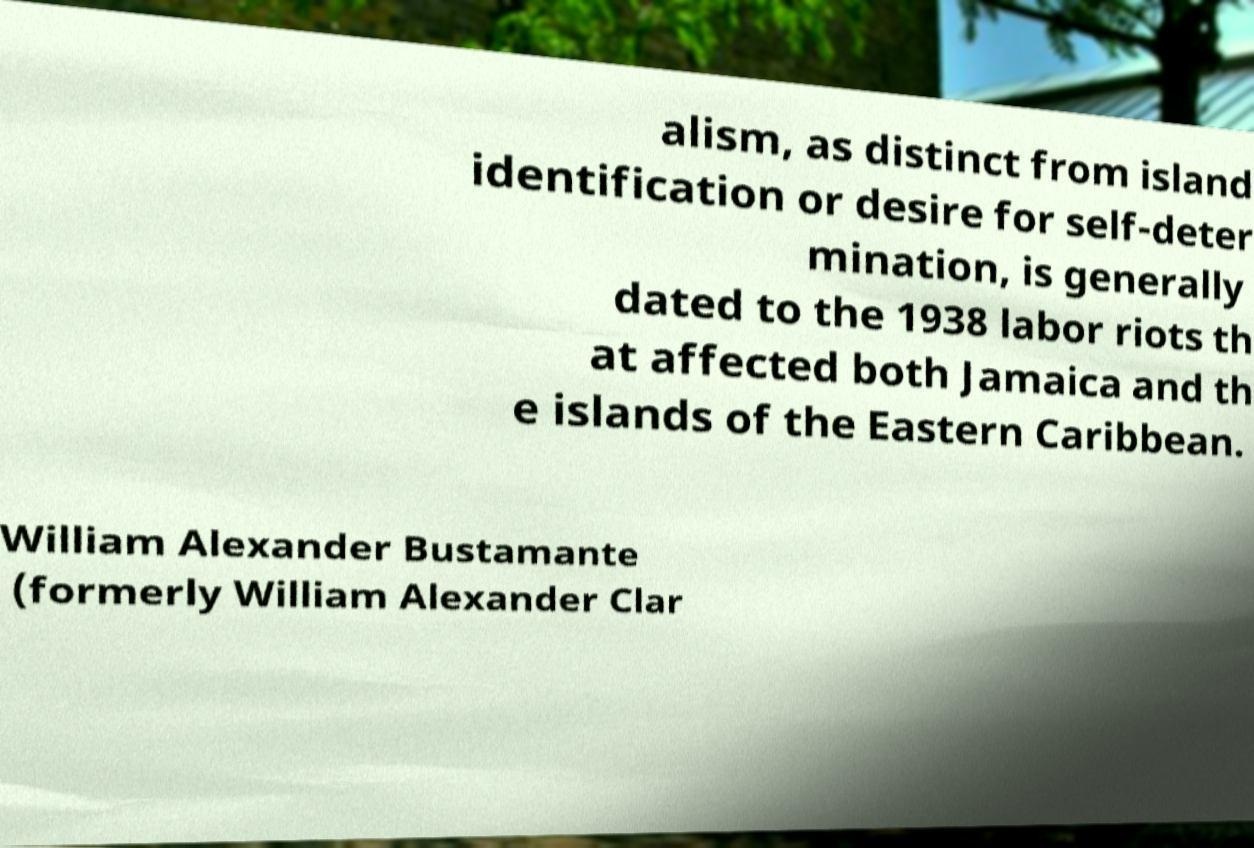For documentation purposes, I need the text within this image transcribed. Could you provide that? alism, as distinct from island identification or desire for self-deter mination, is generally dated to the 1938 labor riots th at affected both Jamaica and th e islands of the Eastern Caribbean. William Alexander Bustamante (formerly William Alexander Clar 